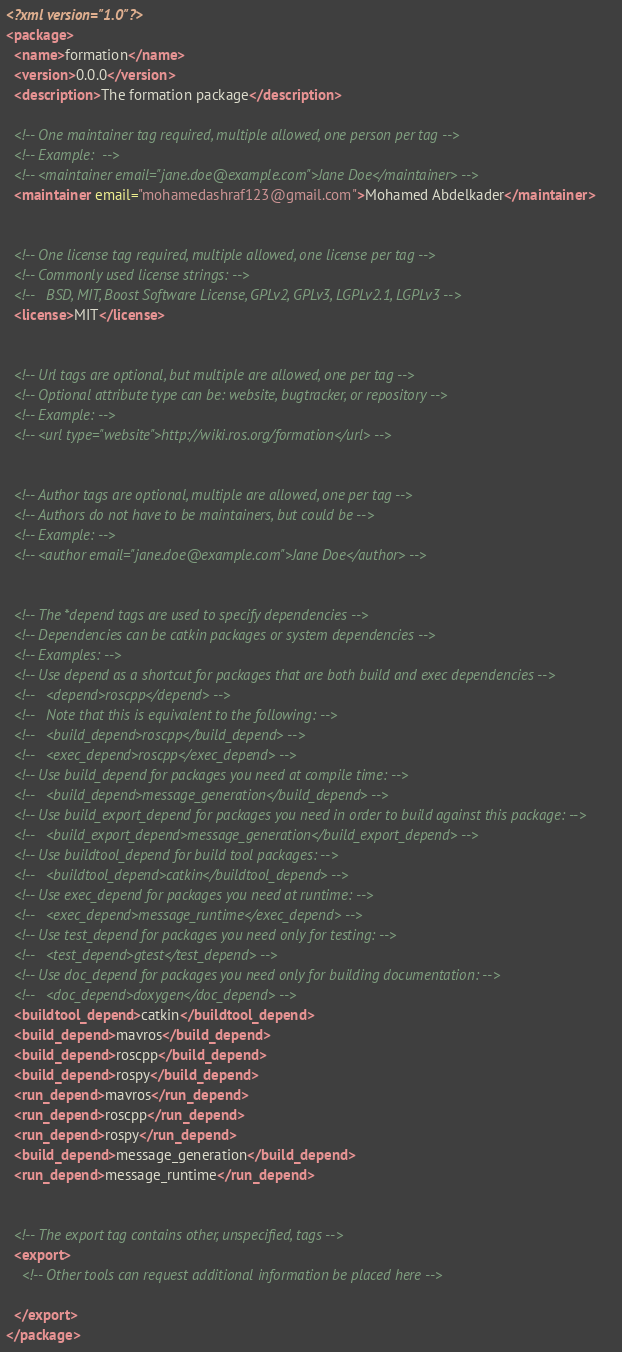Convert code to text. <code><loc_0><loc_0><loc_500><loc_500><_XML_><?xml version="1.0"?>
<package>
  <name>formation</name>
  <version>0.0.0</version>
  <description>The formation package</description>

  <!-- One maintainer tag required, multiple allowed, one person per tag -->
  <!-- Example:  -->
  <!-- <maintainer email="jane.doe@example.com">Jane Doe</maintainer> -->
  <maintainer email="mohamedashraf123@gmail.com">Mohamed Abdelkader</maintainer>


  <!-- One license tag required, multiple allowed, one license per tag -->
  <!-- Commonly used license strings: -->
  <!--   BSD, MIT, Boost Software License, GPLv2, GPLv3, LGPLv2.1, LGPLv3 -->
  <license>MIT</license>


  <!-- Url tags are optional, but multiple are allowed, one per tag -->
  <!-- Optional attribute type can be: website, bugtracker, or repository -->
  <!-- Example: -->
  <!-- <url type="website">http://wiki.ros.org/formation</url> -->


  <!-- Author tags are optional, multiple are allowed, one per tag -->
  <!-- Authors do not have to be maintainers, but could be -->
  <!-- Example: -->
  <!-- <author email="jane.doe@example.com">Jane Doe</author> -->


  <!-- The *depend tags are used to specify dependencies -->
  <!-- Dependencies can be catkin packages or system dependencies -->
  <!-- Examples: -->
  <!-- Use depend as a shortcut for packages that are both build and exec dependencies -->
  <!--   <depend>roscpp</depend> -->
  <!--   Note that this is equivalent to the following: -->
  <!--   <build_depend>roscpp</build_depend> -->
  <!--   <exec_depend>roscpp</exec_depend> -->
  <!-- Use build_depend for packages you need at compile time: -->
  <!--   <build_depend>message_generation</build_depend> -->
  <!-- Use build_export_depend for packages you need in order to build against this package: -->
  <!--   <build_export_depend>message_generation</build_export_depend> -->
  <!-- Use buildtool_depend for build tool packages: -->
  <!--   <buildtool_depend>catkin</buildtool_depend> -->
  <!-- Use exec_depend for packages you need at runtime: -->
  <!--   <exec_depend>message_runtime</exec_depend> -->
  <!-- Use test_depend for packages you need only for testing: -->
  <!--   <test_depend>gtest</test_depend> -->
  <!-- Use doc_depend for packages you need only for building documentation: -->
  <!--   <doc_depend>doxygen</doc_depend> -->
  <buildtool_depend>catkin</buildtool_depend>
  <build_depend>mavros</build_depend>
  <build_depend>roscpp</build_depend>
  <build_depend>rospy</build_depend>
  <run_depend>mavros</run_depend>
  <run_depend>roscpp</run_depend>
  <run_depend>rospy</run_depend>
  <build_depend>message_generation</build_depend>
  <run_depend>message_runtime</run_depend>


  <!-- The export tag contains other, unspecified, tags -->
  <export>
    <!-- Other tools can request additional information be placed here -->

  </export>
</package>
</code> 